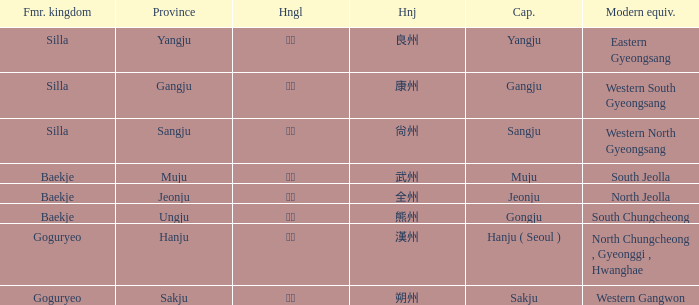What is the hanja for the province of "sangju"? 尙州. 